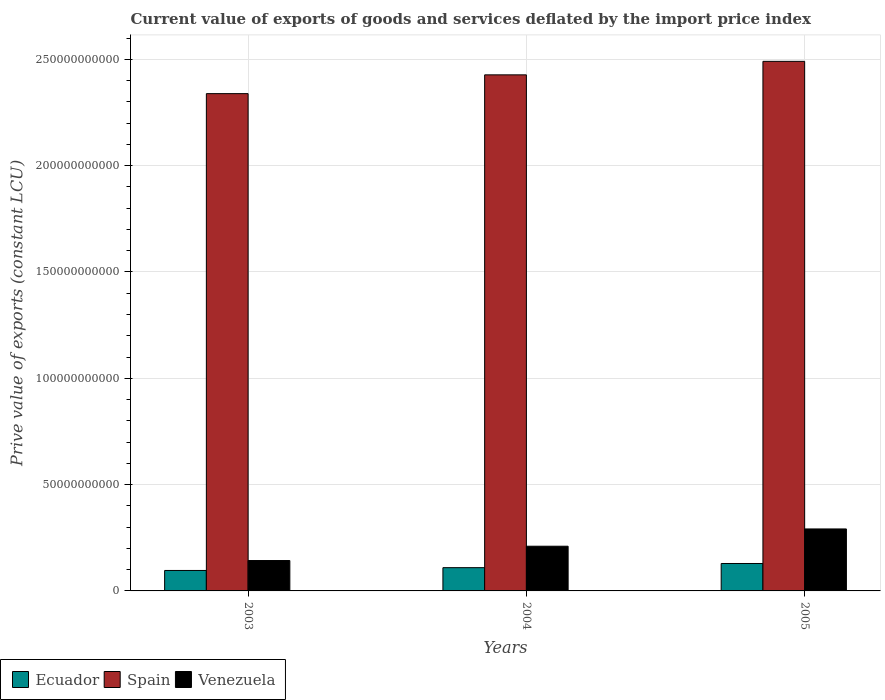How many different coloured bars are there?
Your response must be concise. 3. Are the number of bars per tick equal to the number of legend labels?
Offer a terse response. Yes. How many bars are there on the 3rd tick from the left?
Provide a short and direct response. 3. How many bars are there on the 3rd tick from the right?
Your answer should be compact. 3. What is the prive value of exports in Venezuela in 2004?
Ensure brevity in your answer.  2.10e+1. Across all years, what is the maximum prive value of exports in Ecuador?
Provide a succinct answer. 1.29e+1. Across all years, what is the minimum prive value of exports in Spain?
Offer a terse response. 2.34e+11. In which year was the prive value of exports in Venezuela maximum?
Ensure brevity in your answer.  2005. What is the total prive value of exports in Spain in the graph?
Make the answer very short. 7.26e+11. What is the difference between the prive value of exports in Spain in 2004 and that in 2005?
Offer a very short reply. -6.35e+09. What is the difference between the prive value of exports in Venezuela in 2003 and the prive value of exports in Spain in 2004?
Make the answer very short. -2.28e+11. What is the average prive value of exports in Ecuador per year?
Keep it short and to the point. 1.12e+1. In the year 2003, what is the difference between the prive value of exports in Venezuela and prive value of exports in Ecuador?
Offer a very short reply. 4.67e+09. In how many years, is the prive value of exports in Ecuador greater than 250000000000 LCU?
Offer a very short reply. 0. What is the ratio of the prive value of exports in Ecuador in 2004 to that in 2005?
Provide a succinct answer. 0.85. Is the prive value of exports in Ecuador in 2003 less than that in 2005?
Ensure brevity in your answer.  Yes. Is the difference between the prive value of exports in Venezuela in 2003 and 2004 greater than the difference between the prive value of exports in Ecuador in 2003 and 2004?
Your response must be concise. No. What is the difference between the highest and the second highest prive value of exports in Venezuela?
Ensure brevity in your answer.  8.13e+09. What is the difference between the highest and the lowest prive value of exports in Venezuela?
Your answer should be compact. 1.49e+1. In how many years, is the prive value of exports in Ecuador greater than the average prive value of exports in Ecuador taken over all years?
Offer a very short reply. 1. What does the 2nd bar from the left in 2003 represents?
Offer a very short reply. Spain. What does the 2nd bar from the right in 2004 represents?
Give a very brief answer. Spain. Are all the bars in the graph horizontal?
Keep it short and to the point. No. How many years are there in the graph?
Offer a terse response. 3. Does the graph contain any zero values?
Your response must be concise. No. Where does the legend appear in the graph?
Keep it short and to the point. Bottom left. What is the title of the graph?
Your answer should be very brief. Current value of exports of goods and services deflated by the import price index. Does "East Asia (all income levels)" appear as one of the legend labels in the graph?
Provide a short and direct response. No. What is the label or title of the X-axis?
Your answer should be compact. Years. What is the label or title of the Y-axis?
Offer a terse response. Prive value of exports (constant LCU). What is the Prive value of exports (constant LCU) in Ecuador in 2003?
Make the answer very short. 9.62e+09. What is the Prive value of exports (constant LCU) of Spain in 2003?
Give a very brief answer. 2.34e+11. What is the Prive value of exports (constant LCU) of Venezuela in 2003?
Your response must be concise. 1.43e+1. What is the Prive value of exports (constant LCU) of Ecuador in 2004?
Ensure brevity in your answer.  1.09e+1. What is the Prive value of exports (constant LCU) of Spain in 2004?
Keep it short and to the point. 2.43e+11. What is the Prive value of exports (constant LCU) in Venezuela in 2004?
Ensure brevity in your answer.  2.10e+1. What is the Prive value of exports (constant LCU) of Ecuador in 2005?
Offer a terse response. 1.29e+1. What is the Prive value of exports (constant LCU) of Spain in 2005?
Your answer should be very brief. 2.49e+11. What is the Prive value of exports (constant LCU) in Venezuela in 2005?
Make the answer very short. 2.91e+1. Across all years, what is the maximum Prive value of exports (constant LCU) in Ecuador?
Give a very brief answer. 1.29e+1. Across all years, what is the maximum Prive value of exports (constant LCU) in Spain?
Provide a short and direct response. 2.49e+11. Across all years, what is the maximum Prive value of exports (constant LCU) of Venezuela?
Provide a short and direct response. 2.91e+1. Across all years, what is the minimum Prive value of exports (constant LCU) in Ecuador?
Offer a very short reply. 9.62e+09. Across all years, what is the minimum Prive value of exports (constant LCU) of Spain?
Make the answer very short. 2.34e+11. Across all years, what is the minimum Prive value of exports (constant LCU) in Venezuela?
Make the answer very short. 1.43e+1. What is the total Prive value of exports (constant LCU) in Ecuador in the graph?
Provide a short and direct response. 3.35e+1. What is the total Prive value of exports (constant LCU) in Spain in the graph?
Give a very brief answer. 7.26e+11. What is the total Prive value of exports (constant LCU) of Venezuela in the graph?
Your response must be concise. 6.45e+1. What is the difference between the Prive value of exports (constant LCU) of Ecuador in 2003 and that in 2004?
Offer a terse response. -1.32e+09. What is the difference between the Prive value of exports (constant LCU) in Spain in 2003 and that in 2004?
Offer a very short reply. -8.84e+09. What is the difference between the Prive value of exports (constant LCU) in Venezuela in 2003 and that in 2004?
Your answer should be very brief. -6.73e+09. What is the difference between the Prive value of exports (constant LCU) of Ecuador in 2003 and that in 2005?
Offer a very short reply. -3.28e+09. What is the difference between the Prive value of exports (constant LCU) of Spain in 2003 and that in 2005?
Keep it short and to the point. -1.52e+1. What is the difference between the Prive value of exports (constant LCU) in Venezuela in 2003 and that in 2005?
Keep it short and to the point. -1.49e+1. What is the difference between the Prive value of exports (constant LCU) in Ecuador in 2004 and that in 2005?
Keep it short and to the point. -1.96e+09. What is the difference between the Prive value of exports (constant LCU) of Spain in 2004 and that in 2005?
Offer a terse response. -6.35e+09. What is the difference between the Prive value of exports (constant LCU) in Venezuela in 2004 and that in 2005?
Give a very brief answer. -8.13e+09. What is the difference between the Prive value of exports (constant LCU) of Ecuador in 2003 and the Prive value of exports (constant LCU) of Spain in 2004?
Give a very brief answer. -2.33e+11. What is the difference between the Prive value of exports (constant LCU) of Ecuador in 2003 and the Prive value of exports (constant LCU) of Venezuela in 2004?
Make the answer very short. -1.14e+1. What is the difference between the Prive value of exports (constant LCU) in Spain in 2003 and the Prive value of exports (constant LCU) in Venezuela in 2004?
Ensure brevity in your answer.  2.13e+11. What is the difference between the Prive value of exports (constant LCU) in Ecuador in 2003 and the Prive value of exports (constant LCU) in Spain in 2005?
Keep it short and to the point. -2.39e+11. What is the difference between the Prive value of exports (constant LCU) in Ecuador in 2003 and the Prive value of exports (constant LCU) in Venezuela in 2005?
Make the answer very short. -1.95e+1. What is the difference between the Prive value of exports (constant LCU) of Spain in 2003 and the Prive value of exports (constant LCU) of Venezuela in 2005?
Make the answer very short. 2.05e+11. What is the difference between the Prive value of exports (constant LCU) in Ecuador in 2004 and the Prive value of exports (constant LCU) in Spain in 2005?
Keep it short and to the point. -2.38e+11. What is the difference between the Prive value of exports (constant LCU) of Ecuador in 2004 and the Prive value of exports (constant LCU) of Venezuela in 2005?
Provide a short and direct response. -1.82e+1. What is the difference between the Prive value of exports (constant LCU) in Spain in 2004 and the Prive value of exports (constant LCU) in Venezuela in 2005?
Your response must be concise. 2.14e+11. What is the average Prive value of exports (constant LCU) in Ecuador per year?
Your response must be concise. 1.12e+1. What is the average Prive value of exports (constant LCU) of Spain per year?
Provide a succinct answer. 2.42e+11. What is the average Prive value of exports (constant LCU) of Venezuela per year?
Make the answer very short. 2.15e+1. In the year 2003, what is the difference between the Prive value of exports (constant LCU) of Ecuador and Prive value of exports (constant LCU) of Spain?
Provide a short and direct response. -2.24e+11. In the year 2003, what is the difference between the Prive value of exports (constant LCU) of Ecuador and Prive value of exports (constant LCU) of Venezuela?
Give a very brief answer. -4.67e+09. In the year 2003, what is the difference between the Prive value of exports (constant LCU) of Spain and Prive value of exports (constant LCU) of Venezuela?
Offer a very short reply. 2.20e+11. In the year 2004, what is the difference between the Prive value of exports (constant LCU) in Ecuador and Prive value of exports (constant LCU) in Spain?
Make the answer very short. -2.32e+11. In the year 2004, what is the difference between the Prive value of exports (constant LCU) in Ecuador and Prive value of exports (constant LCU) in Venezuela?
Offer a very short reply. -1.01e+1. In the year 2004, what is the difference between the Prive value of exports (constant LCU) of Spain and Prive value of exports (constant LCU) of Venezuela?
Give a very brief answer. 2.22e+11. In the year 2005, what is the difference between the Prive value of exports (constant LCU) in Ecuador and Prive value of exports (constant LCU) in Spain?
Keep it short and to the point. -2.36e+11. In the year 2005, what is the difference between the Prive value of exports (constant LCU) in Ecuador and Prive value of exports (constant LCU) in Venezuela?
Offer a terse response. -1.62e+1. In the year 2005, what is the difference between the Prive value of exports (constant LCU) of Spain and Prive value of exports (constant LCU) of Venezuela?
Make the answer very short. 2.20e+11. What is the ratio of the Prive value of exports (constant LCU) in Ecuador in 2003 to that in 2004?
Your answer should be very brief. 0.88. What is the ratio of the Prive value of exports (constant LCU) of Spain in 2003 to that in 2004?
Offer a terse response. 0.96. What is the ratio of the Prive value of exports (constant LCU) of Venezuela in 2003 to that in 2004?
Keep it short and to the point. 0.68. What is the ratio of the Prive value of exports (constant LCU) of Ecuador in 2003 to that in 2005?
Ensure brevity in your answer.  0.75. What is the ratio of the Prive value of exports (constant LCU) in Spain in 2003 to that in 2005?
Give a very brief answer. 0.94. What is the ratio of the Prive value of exports (constant LCU) in Venezuela in 2003 to that in 2005?
Make the answer very short. 0.49. What is the ratio of the Prive value of exports (constant LCU) in Ecuador in 2004 to that in 2005?
Provide a short and direct response. 0.85. What is the ratio of the Prive value of exports (constant LCU) of Spain in 2004 to that in 2005?
Provide a short and direct response. 0.97. What is the ratio of the Prive value of exports (constant LCU) in Venezuela in 2004 to that in 2005?
Your answer should be very brief. 0.72. What is the difference between the highest and the second highest Prive value of exports (constant LCU) of Ecuador?
Give a very brief answer. 1.96e+09. What is the difference between the highest and the second highest Prive value of exports (constant LCU) in Spain?
Make the answer very short. 6.35e+09. What is the difference between the highest and the second highest Prive value of exports (constant LCU) of Venezuela?
Ensure brevity in your answer.  8.13e+09. What is the difference between the highest and the lowest Prive value of exports (constant LCU) of Ecuador?
Make the answer very short. 3.28e+09. What is the difference between the highest and the lowest Prive value of exports (constant LCU) of Spain?
Give a very brief answer. 1.52e+1. What is the difference between the highest and the lowest Prive value of exports (constant LCU) in Venezuela?
Keep it short and to the point. 1.49e+1. 